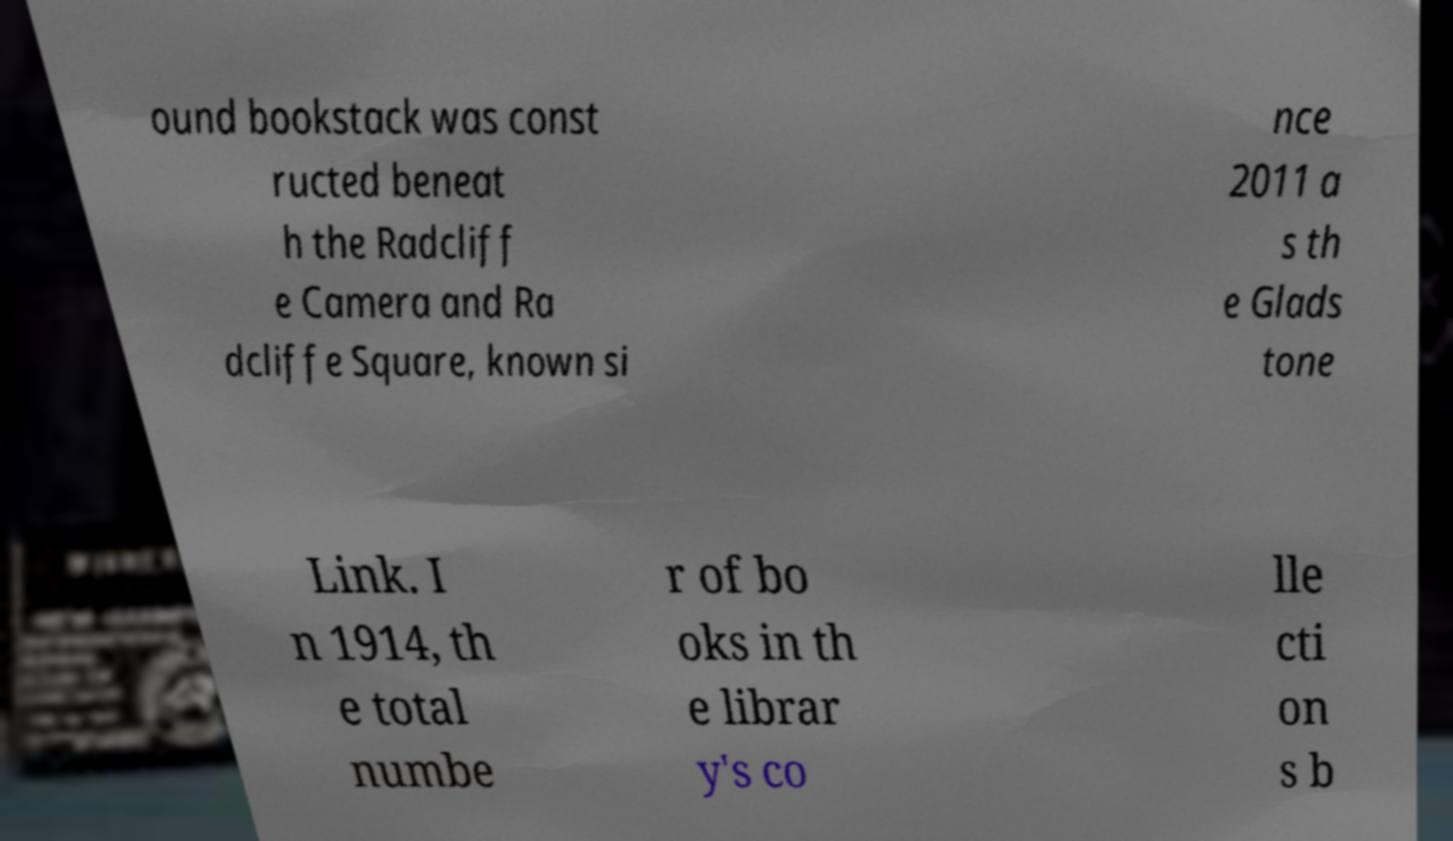I need the written content from this picture converted into text. Can you do that? ound bookstack was const ructed beneat h the Radcliff e Camera and Ra dcliffe Square, known si nce 2011 a s th e Glads tone Link. I n 1914, th e total numbe r of bo oks in th e librar y's co lle cti on s b 